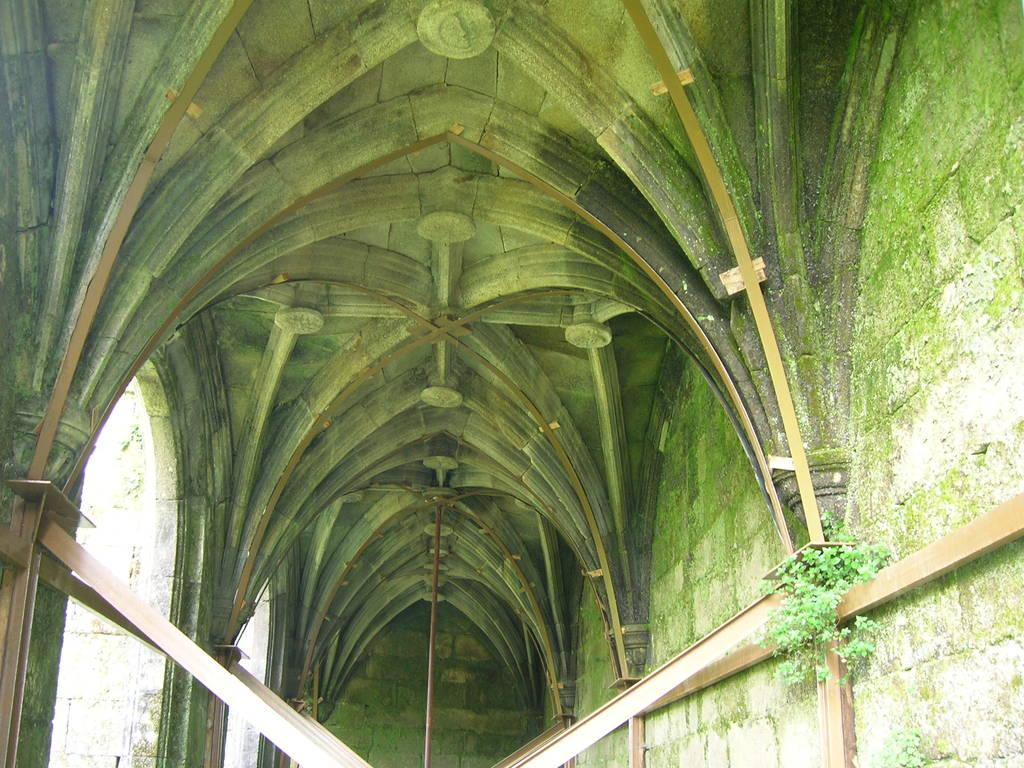What type of architectural feature can be seen in the image? There are arches in the image. What else is present in the image besides the arches? There are poles and a plant in the image. Can you describe the plant in the image? Unfortunately, the facts provided do not specify the type of plant in the image. Are there any other objects or features in the image that are not mentioned in the facts? Yes, there are other unspecified things in the image. How many ants can be seen crawling on the bridge in the image? There is no bridge or ants present in the image. 